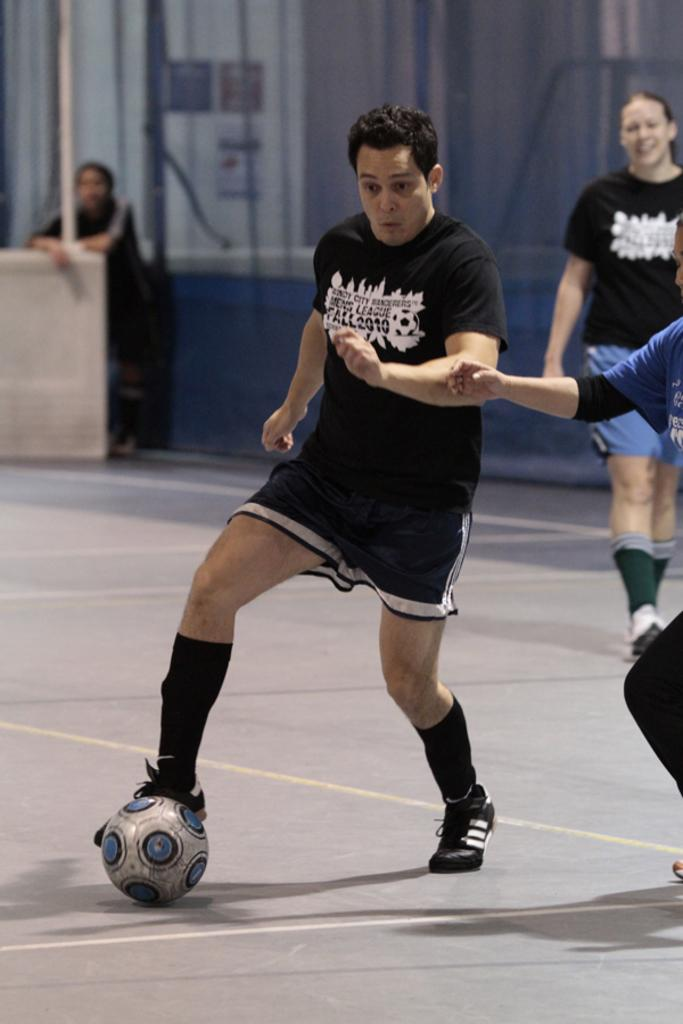What are the people in the image doing? The people in the image are standing on the ground. What object is beside the people? There is a ball beside the people. What type of covering can be seen in the image? There is a curtain visible in the image. Can you describe the position of one of the people in the image? There is a person standing beside a pole in the image. What type of pot is hanging from the cloud in the image? There is no cloud or pot present in the image. 